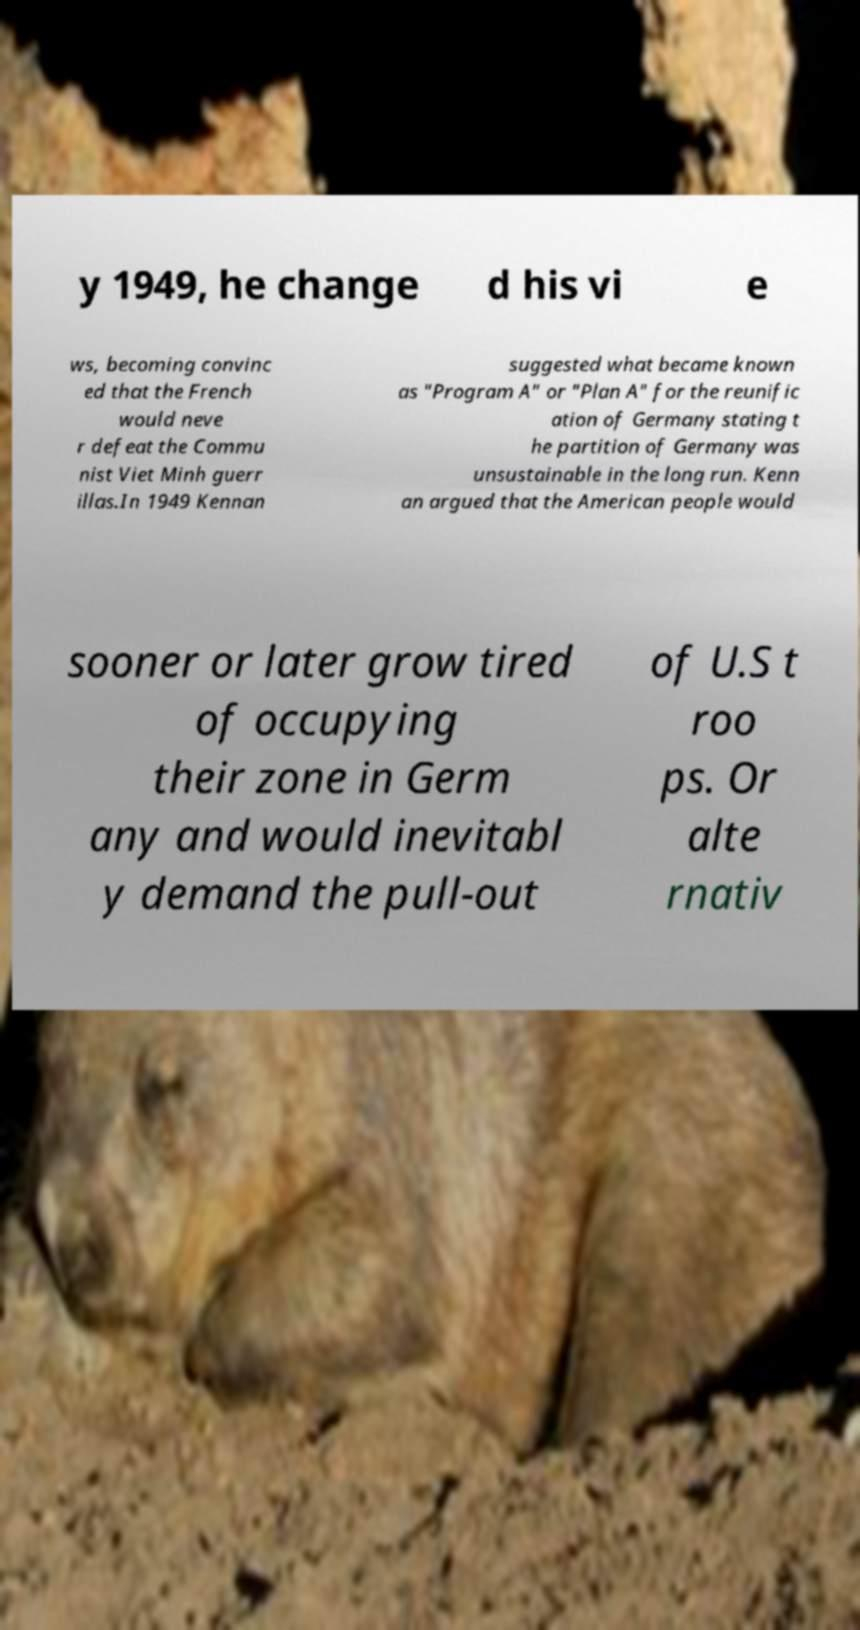Please read and relay the text visible in this image. What does it say? y 1949, he change d his vi e ws, becoming convinc ed that the French would neve r defeat the Commu nist Viet Minh guerr illas.In 1949 Kennan suggested what became known as "Program A" or "Plan A" for the reunific ation of Germany stating t he partition of Germany was unsustainable in the long run. Kenn an argued that the American people would sooner or later grow tired of occupying their zone in Germ any and would inevitabl y demand the pull-out of U.S t roo ps. Or alte rnativ 